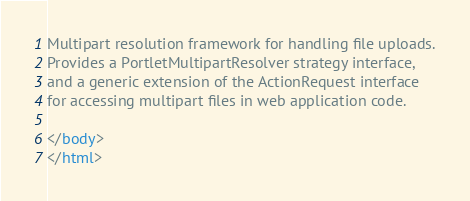Convert code to text. <code><loc_0><loc_0><loc_500><loc_500><_HTML_>
Multipart resolution framework for handling file uploads.
Provides a PortletMultipartResolver strategy interface,
and a generic extension of the ActionRequest interface
for accessing multipart files in web application code.

</body>
</html>
</code> 